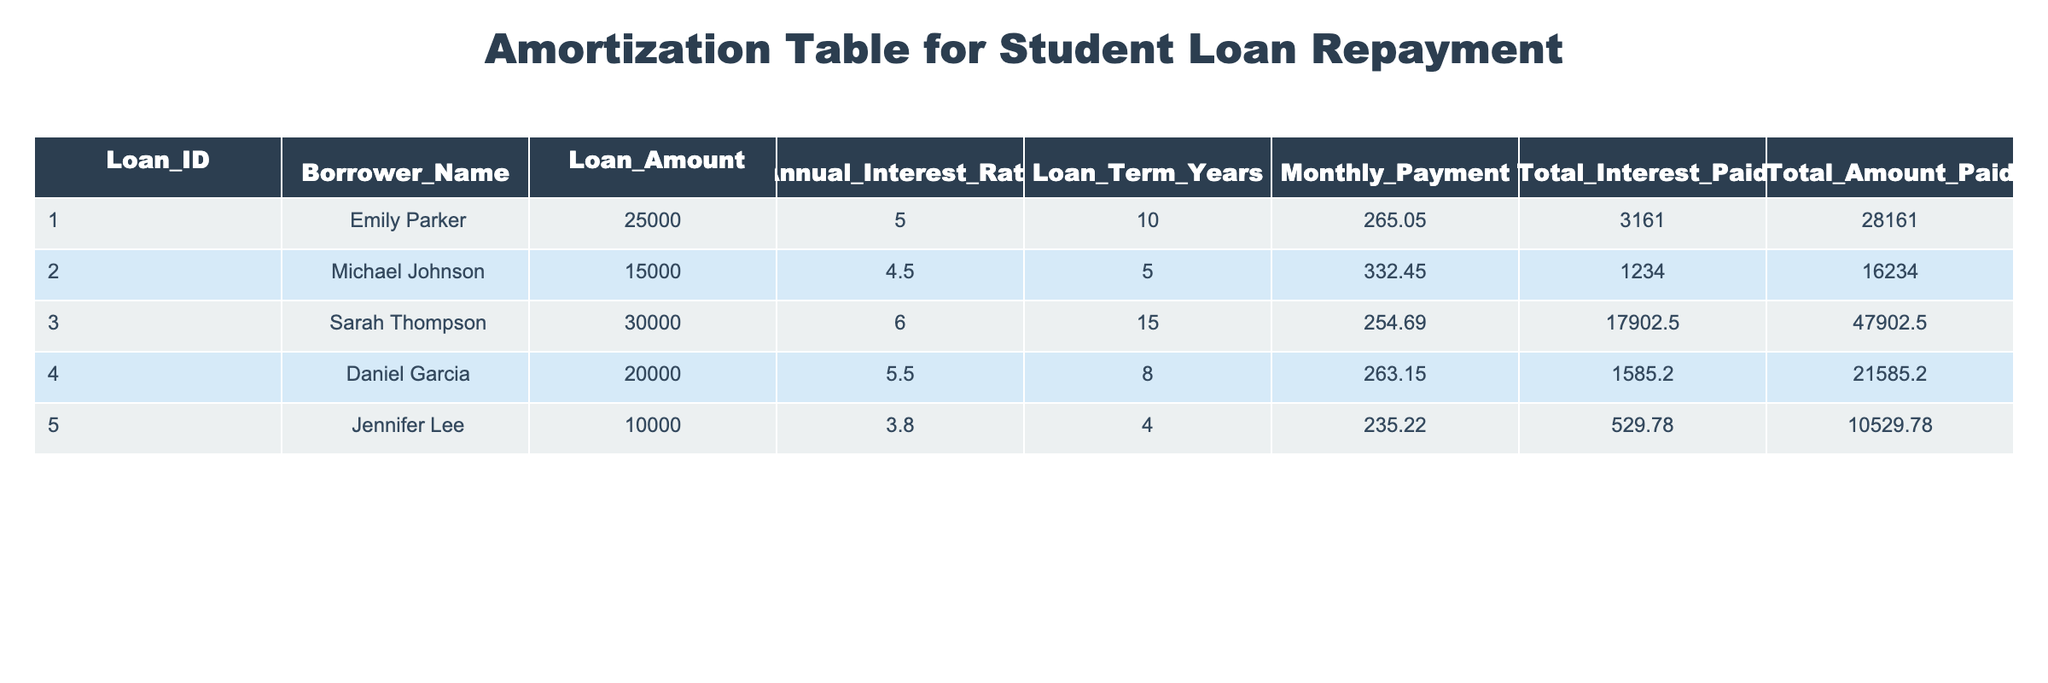What is the loan amount for Sarah Thompson? The loan amount for each borrower is listed in the "Loan_Amount" column. For Sarah Thompson, it shows 30000.
Answer: 30000 What is the total interest paid by Emily Parker? The total interest paid is shown in the "Total_Interest_Paid" column. For Emily Parker, this value is 3161.00.
Answer: 3161.00 Which borrower has the highest monthly payment? We need to compare the "Monthly_Payment" values for all borrowers. Michael Johnson has the highest monthly payment of 332.45.
Answer: Michael Johnson What is the average total amount paid across all loans? The total amounts paid are: 28161.00, 16234.00, 47902.50, 21585.20, and 10529.78. We sum these values to get 124012.48 and divide by the number of loans (5): 124012.48 / 5 = 24802.496.
Answer: 24802.496 Did any borrower pay more than 20000 in total interest? We need to look at the "Total_Interest_Paid" column. Only Sarah Thompson paid 17902.50, which is less than 20000, so the answer is no.
Answer: No What is the difference in total amount paid between Daniel Garcia and Jennifer Lee? We look at the "Total_Amount_Paid" for Daniel Garcia, which is 21585.20, and for Jennifer Lee, it is 10529.78. Calculating the difference gives us 21585.20 - 10529.78 = 11055.42.
Answer: 11055.42 Which borrower's loan term is the longest? The loan terms are listed in the "Loan_Term_Years" column. Sarah Thompson has the longest term of 15 years.
Answer: Sarah Thompson What is the total loan amount for all borrowers? We sum the "Loan_Amount" values for each borrower: 25000 + 15000 + 30000 + 20000 + 10000 = 100000.
Answer: 100000 Which borrowers have an annual interest rate of 5.0% or higher? We check the "Annual_Interest_Rate" column and find that Emily Parker, Daniel Garcia, and Sarah Thompson have rates of 5.0, 5.5, and 6.0 respectively.
Answer: Emily Parker, Daniel Garcia, Sarah Thompson 